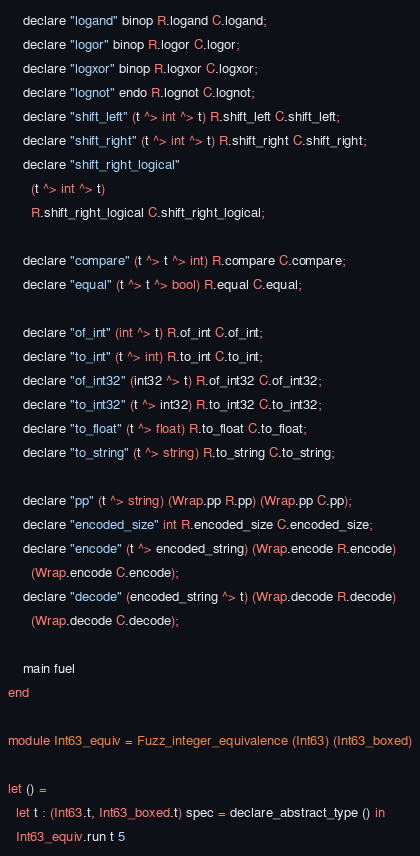<code> <loc_0><loc_0><loc_500><loc_500><_OCaml_>    declare "logand" binop R.logand C.logand;
    declare "logor" binop R.logor C.logor;
    declare "logxor" binop R.logxor C.logxor;
    declare "lognot" endo R.lognot C.lognot;
    declare "shift_left" (t ^> int ^> t) R.shift_left C.shift_left;
    declare "shift_right" (t ^> int ^> t) R.shift_right C.shift_right;
    declare "shift_right_logical"
      (t ^> int ^> t)
      R.shift_right_logical C.shift_right_logical;

    declare "compare" (t ^> t ^> int) R.compare C.compare;
    declare "equal" (t ^> t ^> bool) R.equal C.equal;

    declare "of_int" (int ^> t) R.of_int C.of_int;
    declare "to_int" (t ^> int) R.to_int C.to_int;
    declare "of_int32" (int32 ^> t) R.of_int32 C.of_int32;
    declare "to_int32" (t ^> int32) R.to_int32 C.to_int32;
    declare "to_float" (t ^> float) R.to_float C.to_float;
    declare "to_string" (t ^> string) R.to_string C.to_string;

    declare "pp" (t ^> string) (Wrap.pp R.pp) (Wrap.pp C.pp);
    declare "encoded_size" int R.encoded_size C.encoded_size;
    declare "encode" (t ^> encoded_string) (Wrap.encode R.encode)
      (Wrap.encode C.encode);
    declare "decode" (encoded_string ^> t) (Wrap.decode R.decode)
      (Wrap.decode C.decode);

    main fuel
end

module Int63_equiv = Fuzz_integer_equivalence (Int63) (Int63_boxed)

let () =
  let t : (Int63.t, Int63_boxed.t) spec = declare_abstract_type () in
  Int63_equiv.run t 5
</code> 